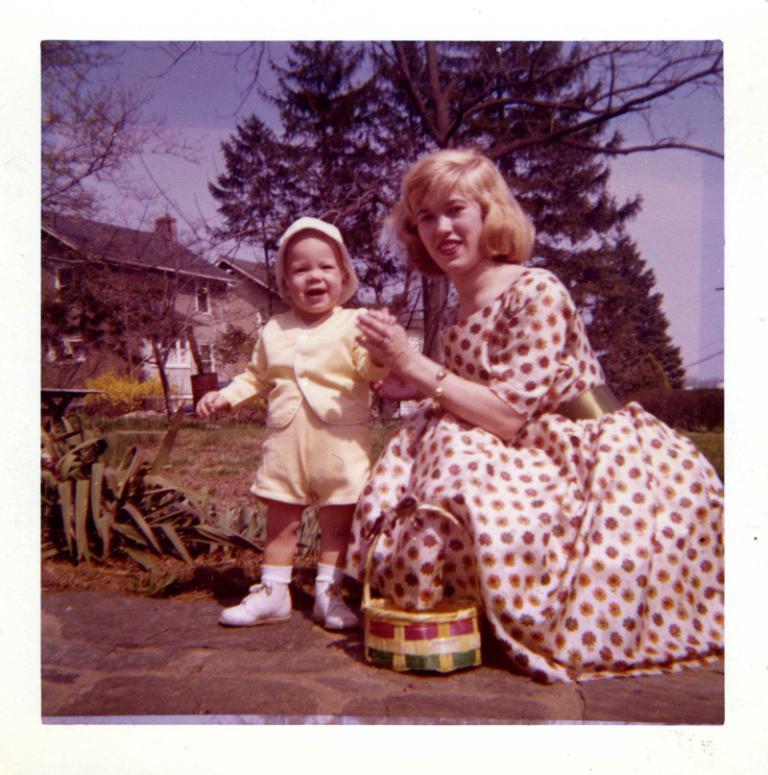Please provide a concise description of this image. In the image we can see a woman and a child wearing clothes. The child is wearing socks, shoes and a cap. This is a bracelet, basket, footpath, plant, grass, trees and a sky. We can even see a building and the windows of the building. 